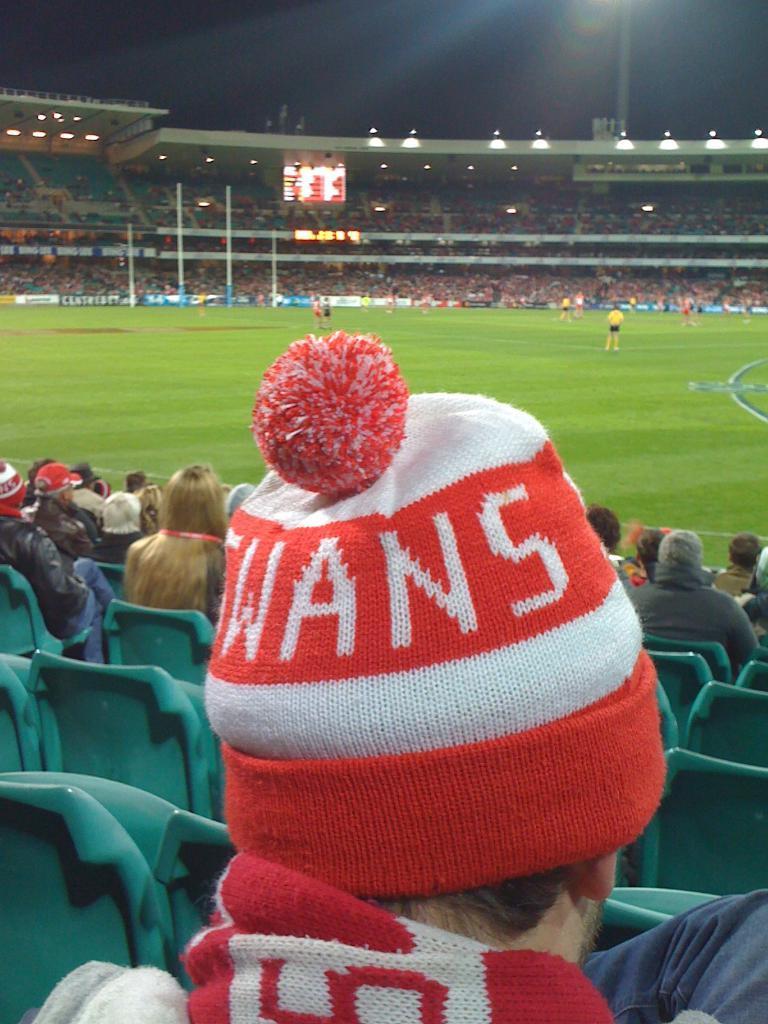In one or two sentences, can you explain what this image depicts? In the foreground of this image, there is a person wearing stole and a cap. In the background, there are persons siting on the chairs, few persons on the play ground. In the background, there is stadium and the dark sky. 